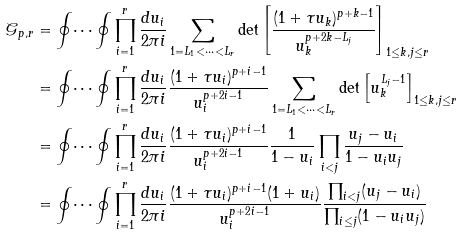Convert formula to latex. <formula><loc_0><loc_0><loc_500><loc_500>\mathcal { G } _ { p , r } & = \oint \dots \oint \prod _ { i = 1 } ^ { r } \frac { d u _ { i } } { 2 \pi i } \sum _ { 1 = L _ { 1 } < \dots < L _ { r } } \det \left [ \frac { ( 1 + \tau u _ { k } ) ^ { p + k - 1 } } { u _ { k } ^ { p + 2 k - L _ { j } } } \right ] _ { 1 \leq k , j \leq r } \\ & = \oint \dots \oint \prod _ { i = 1 } ^ { r } \frac { d u _ { i } } { 2 \pi i } \frac { ( 1 + \tau u _ { i } ) ^ { p + i - 1 } } { u _ { i } ^ { p + 2 i - 1 } } \sum _ { 1 = L _ { 1 } < \dots < L _ { r } } \det \left [ u _ { k } ^ { L _ { j } - 1 } \right ] _ { 1 \leq k , j \leq r } \\ & = \oint \dots \oint \prod _ { i = 1 } ^ { r } \frac { d u _ { i } } { 2 \pi i } \frac { ( 1 + \tau u _ { i } ) ^ { p + i - 1 } } { u _ { i } ^ { p + 2 i - 1 } } \frac { 1 } { 1 - u _ { i } } \prod _ { i < j } \frac { u _ { j } - u _ { i } } { 1 - u _ { i } u _ { j } } \\ & = \oint \dots \oint \prod _ { i = 1 } ^ { r } \frac { d u _ { i } } { 2 \pi i } \frac { ( 1 + \tau u _ { i } ) ^ { p + i - 1 } ( 1 + u _ { i } ) } { u _ { i } ^ { p + 2 i - 1 } } \frac { \prod _ { i < j } ( u _ { j } - u _ { i } ) } { \prod _ { i \leq j } ( 1 - u _ { i } u _ { j } ) } \\</formula> 